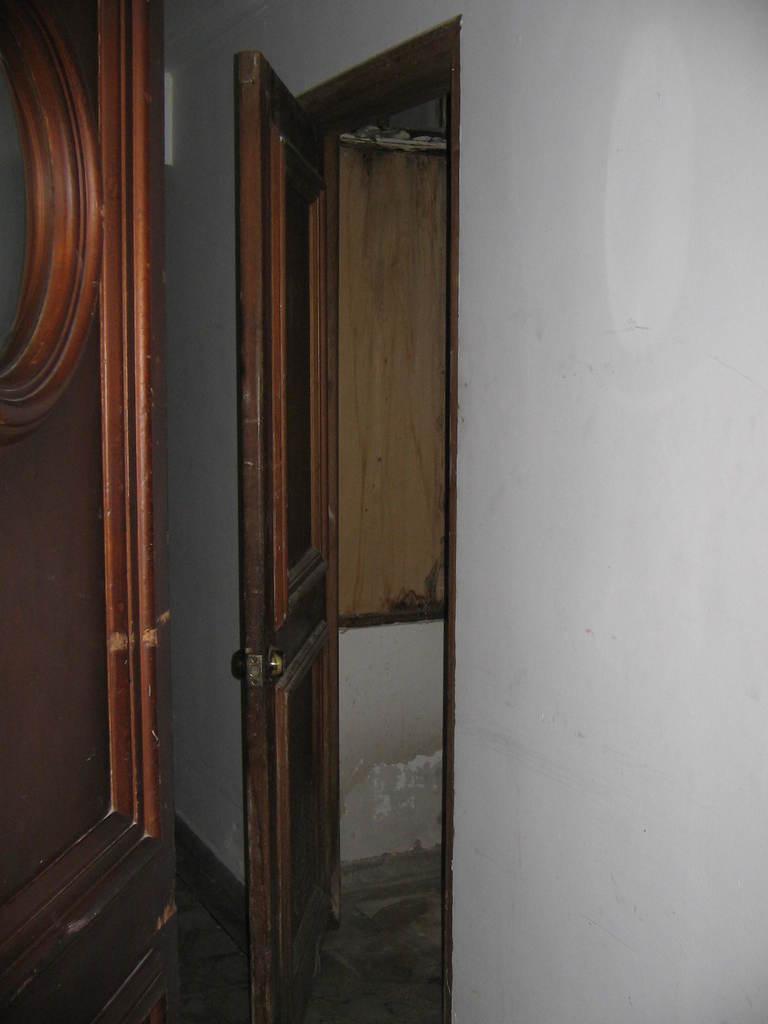Could you give a brief overview of what you see in this image? In this image we can see the door and the wall. 